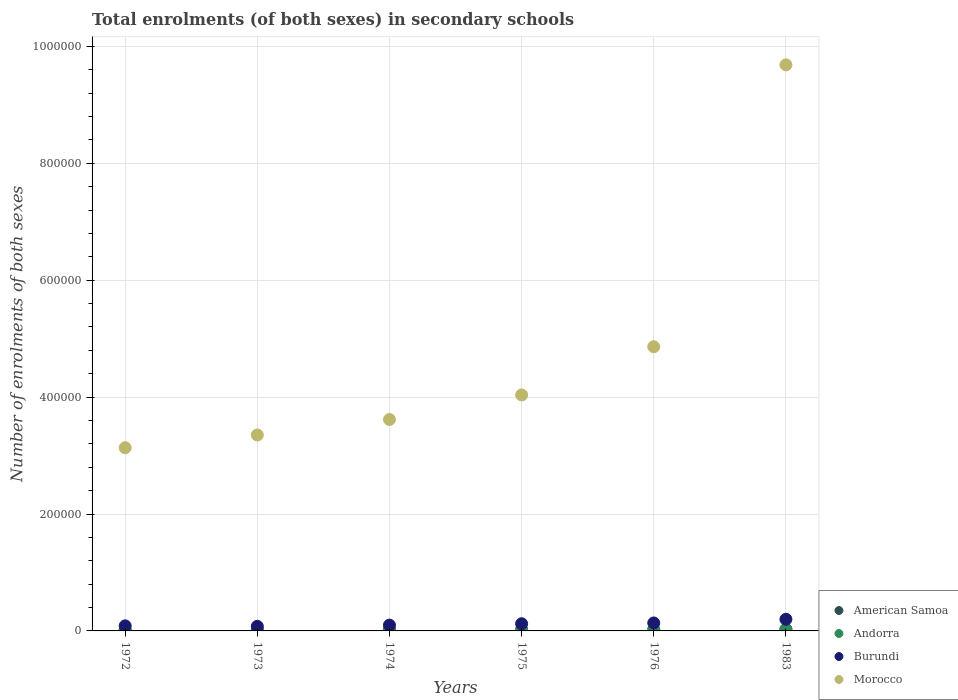How many different coloured dotlines are there?
Offer a terse response. 4. Is the number of dotlines equal to the number of legend labels?
Make the answer very short. Yes. What is the number of enrolments in secondary schools in Burundi in 1983?
Your answer should be very brief. 1.99e+04. Across all years, what is the maximum number of enrolments in secondary schools in Morocco?
Keep it short and to the point. 9.68e+05. Across all years, what is the minimum number of enrolments in secondary schools in Morocco?
Your answer should be very brief. 3.13e+05. In which year was the number of enrolments in secondary schools in American Samoa maximum?
Offer a terse response. 1983. In which year was the number of enrolments in secondary schools in Andorra minimum?
Offer a very short reply. 1973. What is the total number of enrolments in secondary schools in Burundi in the graph?
Your answer should be very brief. 7.23e+04. What is the difference between the number of enrolments in secondary schools in American Samoa in 1974 and that in 1976?
Your answer should be compact. -108. What is the difference between the number of enrolments in secondary schools in Andorra in 1975 and the number of enrolments in secondary schools in American Samoa in 1983?
Provide a succinct answer. -1660. What is the average number of enrolments in secondary schools in Burundi per year?
Ensure brevity in your answer.  1.21e+04. In the year 1976, what is the difference between the number of enrolments in secondary schools in Morocco and number of enrolments in secondary schools in Andorra?
Make the answer very short. 4.84e+05. What is the ratio of the number of enrolments in secondary schools in Andorra in 1972 to that in 1974?
Offer a terse response. 0.81. Is the number of enrolments in secondary schools in Morocco in 1972 less than that in 1973?
Provide a succinct answer. Yes. What is the difference between the highest and the second highest number of enrolments in secondary schools in Burundi?
Provide a short and direct response. 6294. What is the difference between the highest and the lowest number of enrolments in secondary schools in American Samoa?
Give a very brief answer. 694. Is the sum of the number of enrolments in secondary schools in Burundi in 1974 and 1975 greater than the maximum number of enrolments in secondary schools in Morocco across all years?
Your answer should be very brief. No. Is it the case that in every year, the sum of the number of enrolments in secondary schools in Morocco and number of enrolments in secondary schools in Andorra  is greater than the sum of number of enrolments in secondary schools in Burundi and number of enrolments in secondary schools in American Samoa?
Your response must be concise. Yes. Is it the case that in every year, the sum of the number of enrolments in secondary schools in Morocco and number of enrolments in secondary schools in American Samoa  is greater than the number of enrolments in secondary schools in Burundi?
Keep it short and to the point. Yes. How many years are there in the graph?
Provide a short and direct response. 6. Are the values on the major ticks of Y-axis written in scientific E-notation?
Your answer should be very brief. No. How many legend labels are there?
Your answer should be very brief. 4. What is the title of the graph?
Your answer should be compact. Total enrolments (of both sexes) in secondary schools. Does "Somalia" appear as one of the legend labels in the graph?
Provide a short and direct response. No. What is the label or title of the Y-axis?
Make the answer very short. Number of enrolments of both sexes. What is the Number of enrolments of both sexes of American Samoa in 1972?
Provide a succinct answer. 2305. What is the Number of enrolments of both sexes of Andorra in 1972?
Your answer should be compact. 723. What is the Number of enrolments of both sexes of Burundi in 1972?
Ensure brevity in your answer.  8678. What is the Number of enrolments of both sexes of Morocco in 1972?
Offer a very short reply. 3.13e+05. What is the Number of enrolments of both sexes in American Samoa in 1973?
Ensure brevity in your answer.  2484. What is the Number of enrolments of both sexes of Andorra in 1973?
Keep it short and to the point. 698. What is the Number of enrolments of both sexes of Burundi in 1973?
Keep it short and to the point. 7868. What is the Number of enrolments of both sexes in Morocco in 1973?
Your answer should be very brief. 3.35e+05. What is the Number of enrolments of both sexes of American Samoa in 1974?
Keep it short and to the point. 2392. What is the Number of enrolments of both sexes of Andorra in 1974?
Make the answer very short. 890. What is the Number of enrolments of both sexes of Burundi in 1974?
Make the answer very short. 9926. What is the Number of enrolments of both sexes of Morocco in 1974?
Your answer should be very brief. 3.62e+05. What is the Number of enrolments of both sexes in American Samoa in 1975?
Give a very brief answer. 2373. What is the Number of enrolments of both sexes of Andorra in 1975?
Make the answer very short. 1339. What is the Number of enrolments of both sexes in Burundi in 1975?
Provide a short and direct response. 1.23e+04. What is the Number of enrolments of both sexes in Morocco in 1975?
Offer a very short reply. 4.04e+05. What is the Number of enrolments of both sexes in American Samoa in 1976?
Your answer should be compact. 2500. What is the Number of enrolments of both sexes of Andorra in 1976?
Make the answer very short. 1753. What is the Number of enrolments of both sexes of Burundi in 1976?
Your answer should be very brief. 1.36e+04. What is the Number of enrolments of both sexes in Morocco in 1976?
Offer a terse response. 4.86e+05. What is the Number of enrolments of both sexes of American Samoa in 1983?
Keep it short and to the point. 2999. What is the Number of enrolments of both sexes in Andorra in 1983?
Provide a short and direct response. 2516. What is the Number of enrolments of both sexes of Burundi in 1983?
Offer a very short reply. 1.99e+04. What is the Number of enrolments of both sexes of Morocco in 1983?
Your answer should be very brief. 9.68e+05. Across all years, what is the maximum Number of enrolments of both sexes in American Samoa?
Your response must be concise. 2999. Across all years, what is the maximum Number of enrolments of both sexes of Andorra?
Keep it short and to the point. 2516. Across all years, what is the maximum Number of enrolments of both sexes of Burundi?
Ensure brevity in your answer.  1.99e+04. Across all years, what is the maximum Number of enrolments of both sexes of Morocco?
Ensure brevity in your answer.  9.68e+05. Across all years, what is the minimum Number of enrolments of both sexes of American Samoa?
Give a very brief answer. 2305. Across all years, what is the minimum Number of enrolments of both sexes of Andorra?
Offer a very short reply. 698. Across all years, what is the minimum Number of enrolments of both sexes of Burundi?
Give a very brief answer. 7868. Across all years, what is the minimum Number of enrolments of both sexes of Morocco?
Offer a terse response. 3.13e+05. What is the total Number of enrolments of both sexes in American Samoa in the graph?
Provide a succinct answer. 1.51e+04. What is the total Number of enrolments of both sexes in Andorra in the graph?
Your answer should be compact. 7919. What is the total Number of enrolments of both sexes of Burundi in the graph?
Offer a very short reply. 7.23e+04. What is the total Number of enrolments of both sexes of Morocco in the graph?
Keep it short and to the point. 2.87e+06. What is the difference between the Number of enrolments of both sexes of American Samoa in 1972 and that in 1973?
Give a very brief answer. -179. What is the difference between the Number of enrolments of both sexes in Andorra in 1972 and that in 1973?
Your answer should be compact. 25. What is the difference between the Number of enrolments of both sexes in Burundi in 1972 and that in 1973?
Offer a terse response. 810. What is the difference between the Number of enrolments of both sexes in Morocco in 1972 and that in 1973?
Your answer should be very brief. -2.18e+04. What is the difference between the Number of enrolments of both sexes of American Samoa in 1972 and that in 1974?
Your answer should be compact. -87. What is the difference between the Number of enrolments of both sexes of Andorra in 1972 and that in 1974?
Give a very brief answer. -167. What is the difference between the Number of enrolments of both sexes in Burundi in 1972 and that in 1974?
Your answer should be very brief. -1248. What is the difference between the Number of enrolments of both sexes in Morocco in 1972 and that in 1974?
Make the answer very short. -4.83e+04. What is the difference between the Number of enrolments of both sexes of American Samoa in 1972 and that in 1975?
Provide a short and direct response. -68. What is the difference between the Number of enrolments of both sexes of Andorra in 1972 and that in 1975?
Provide a succinct answer. -616. What is the difference between the Number of enrolments of both sexes in Burundi in 1972 and that in 1975?
Your answer should be very brief. -3619. What is the difference between the Number of enrolments of both sexes in Morocco in 1972 and that in 1975?
Offer a very short reply. -9.02e+04. What is the difference between the Number of enrolments of both sexes in American Samoa in 1972 and that in 1976?
Give a very brief answer. -195. What is the difference between the Number of enrolments of both sexes in Andorra in 1972 and that in 1976?
Your answer should be very brief. -1030. What is the difference between the Number of enrolments of both sexes in Burundi in 1972 and that in 1976?
Your response must be concise. -4945. What is the difference between the Number of enrolments of both sexes in Morocco in 1972 and that in 1976?
Your answer should be compact. -1.73e+05. What is the difference between the Number of enrolments of both sexes in American Samoa in 1972 and that in 1983?
Make the answer very short. -694. What is the difference between the Number of enrolments of both sexes of Andorra in 1972 and that in 1983?
Make the answer very short. -1793. What is the difference between the Number of enrolments of both sexes of Burundi in 1972 and that in 1983?
Ensure brevity in your answer.  -1.12e+04. What is the difference between the Number of enrolments of both sexes in Morocco in 1972 and that in 1983?
Ensure brevity in your answer.  -6.55e+05. What is the difference between the Number of enrolments of both sexes of American Samoa in 1973 and that in 1974?
Your answer should be very brief. 92. What is the difference between the Number of enrolments of both sexes of Andorra in 1973 and that in 1974?
Offer a terse response. -192. What is the difference between the Number of enrolments of both sexes in Burundi in 1973 and that in 1974?
Keep it short and to the point. -2058. What is the difference between the Number of enrolments of both sexes of Morocco in 1973 and that in 1974?
Your answer should be compact. -2.65e+04. What is the difference between the Number of enrolments of both sexes in American Samoa in 1973 and that in 1975?
Offer a terse response. 111. What is the difference between the Number of enrolments of both sexes of Andorra in 1973 and that in 1975?
Make the answer very short. -641. What is the difference between the Number of enrolments of both sexes of Burundi in 1973 and that in 1975?
Your answer should be compact. -4429. What is the difference between the Number of enrolments of both sexes in Morocco in 1973 and that in 1975?
Make the answer very short. -6.85e+04. What is the difference between the Number of enrolments of both sexes of Andorra in 1973 and that in 1976?
Keep it short and to the point. -1055. What is the difference between the Number of enrolments of both sexes of Burundi in 1973 and that in 1976?
Give a very brief answer. -5755. What is the difference between the Number of enrolments of both sexes in Morocco in 1973 and that in 1976?
Offer a terse response. -1.51e+05. What is the difference between the Number of enrolments of both sexes in American Samoa in 1973 and that in 1983?
Provide a succinct answer. -515. What is the difference between the Number of enrolments of both sexes of Andorra in 1973 and that in 1983?
Offer a very short reply. -1818. What is the difference between the Number of enrolments of both sexes in Burundi in 1973 and that in 1983?
Keep it short and to the point. -1.20e+04. What is the difference between the Number of enrolments of both sexes of Morocco in 1973 and that in 1983?
Your response must be concise. -6.33e+05. What is the difference between the Number of enrolments of both sexes in American Samoa in 1974 and that in 1975?
Offer a terse response. 19. What is the difference between the Number of enrolments of both sexes in Andorra in 1974 and that in 1975?
Offer a very short reply. -449. What is the difference between the Number of enrolments of both sexes of Burundi in 1974 and that in 1975?
Offer a terse response. -2371. What is the difference between the Number of enrolments of both sexes of Morocco in 1974 and that in 1975?
Make the answer very short. -4.19e+04. What is the difference between the Number of enrolments of both sexes in American Samoa in 1974 and that in 1976?
Ensure brevity in your answer.  -108. What is the difference between the Number of enrolments of both sexes in Andorra in 1974 and that in 1976?
Ensure brevity in your answer.  -863. What is the difference between the Number of enrolments of both sexes in Burundi in 1974 and that in 1976?
Provide a short and direct response. -3697. What is the difference between the Number of enrolments of both sexes of Morocco in 1974 and that in 1976?
Give a very brief answer. -1.24e+05. What is the difference between the Number of enrolments of both sexes in American Samoa in 1974 and that in 1983?
Your answer should be very brief. -607. What is the difference between the Number of enrolments of both sexes in Andorra in 1974 and that in 1983?
Your answer should be very brief. -1626. What is the difference between the Number of enrolments of both sexes of Burundi in 1974 and that in 1983?
Your answer should be very brief. -9991. What is the difference between the Number of enrolments of both sexes of Morocco in 1974 and that in 1983?
Make the answer very short. -6.07e+05. What is the difference between the Number of enrolments of both sexes of American Samoa in 1975 and that in 1976?
Offer a terse response. -127. What is the difference between the Number of enrolments of both sexes in Andorra in 1975 and that in 1976?
Keep it short and to the point. -414. What is the difference between the Number of enrolments of both sexes in Burundi in 1975 and that in 1976?
Offer a terse response. -1326. What is the difference between the Number of enrolments of both sexes in Morocco in 1975 and that in 1976?
Offer a terse response. -8.25e+04. What is the difference between the Number of enrolments of both sexes in American Samoa in 1975 and that in 1983?
Offer a very short reply. -626. What is the difference between the Number of enrolments of both sexes in Andorra in 1975 and that in 1983?
Your answer should be compact. -1177. What is the difference between the Number of enrolments of both sexes in Burundi in 1975 and that in 1983?
Provide a succinct answer. -7620. What is the difference between the Number of enrolments of both sexes of Morocco in 1975 and that in 1983?
Your answer should be very brief. -5.65e+05. What is the difference between the Number of enrolments of both sexes in American Samoa in 1976 and that in 1983?
Give a very brief answer. -499. What is the difference between the Number of enrolments of both sexes in Andorra in 1976 and that in 1983?
Offer a terse response. -763. What is the difference between the Number of enrolments of both sexes of Burundi in 1976 and that in 1983?
Make the answer very short. -6294. What is the difference between the Number of enrolments of both sexes of Morocco in 1976 and that in 1983?
Offer a very short reply. -4.82e+05. What is the difference between the Number of enrolments of both sexes in American Samoa in 1972 and the Number of enrolments of both sexes in Andorra in 1973?
Provide a succinct answer. 1607. What is the difference between the Number of enrolments of both sexes in American Samoa in 1972 and the Number of enrolments of both sexes in Burundi in 1973?
Provide a succinct answer. -5563. What is the difference between the Number of enrolments of both sexes in American Samoa in 1972 and the Number of enrolments of both sexes in Morocco in 1973?
Your answer should be very brief. -3.33e+05. What is the difference between the Number of enrolments of both sexes in Andorra in 1972 and the Number of enrolments of both sexes in Burundi in 1973?
Your answer should be very brief. -7145. What is the difference between the Number of enrolments of both sexes in Andorra in 1972 and the Number of enrolments of both sexes in Morocco in 1973?
Provide a succinct answer. -3.34e+05. What is the difference between the Number of enrolments of both sexes of Burundi in 1972 and the Number of enrolments of both sexes of Morocco in 1973?
Your response must be concise. -3.27e+05. What is the difference between the Number of enrolments of both sexes in American Samoa in 1972 and the Number of enrolments of both sexes in Andorra in 1974?
Your answer should be very brief. 1415. What is the difference between the Number of enrolments of both sexes of American Samoa in 1972 and the Number of enrolments of both sexes of Burundi in 1974?
Give a very brief answer. -7621. What is the difference between the Number of enrolments of both sexes in American Samoa in 1972 and the Number of enrolments of both sexes in Morocco in 1974?
Provide a short and direct response. -3.59e+05. What is the difference between the Number of enrolments of both sexes in Andorra in 1972 and the Number of enrolments of both sexes in Burundi in 1974?
Make the answer very short. -9203. What is the difference between the Number of enrolments of both sexes of Andorra in 1972 and the Number of enrolments of both sexes of Morocco in 1974?
Your response must be concise. -3.61e+05. What is the difference between the Number of enrolments of both sexes of Burundi in 1972 and the Number of enrolments of both sexes of Morocco in 1974?
Give a very brief answer. -3.53e+05. What is the difference between the Number of enrolments of both sexes in American Samoa in 1972 and the Number of enrolments of both sexes in Andorra in 1975?
Ensure brevity in your answer.  966. What is the difference between the Number of enrolments of both sexes in American Samoa in 1972 and the Number of enrolments of both sexes in Burundi in 1975?
Your answer should be very brief. -9992. What is the difference between the Number of enrolments of both sexes in American Samoa in 1972 and the Number of enrolments of both sexes in Morocco in 1975?
Your answer should be compact. -4.01e+05. What is the difference between the Number of enrolments of both sexes in Andorra in 1972 and the Number of enrolments of both sexes in Burundi in 1975?
Give a very brief answer. -1.16e+04. What is the difference between the Number of enrolments of both sexes of Andorra in 1972 and the Number of enrolments of both sexes of Morocco in 1975?
Offer a terse response. -4.03e+05. What is the difference between the Number of enrolments of both sexes in Burundi in 1972 and the Number of enrolments of both sexes in Morocco in 1975?
Give a very brief answer. -3.95e+05. What is the difference between the Number of enrolments of both sexes of American Samoa in 1972 and the Number of enrolments of both sexes of Andorra in 1976?
Provide a succinct answer. 552. What is the difference between the Number of enrolments of both sexes in American Samoa in 1972 and the Number of enrolments of both sexes in Burundi in 1976?
Offer a very short reply. -1.13e+04. What is the difference between the Number of enrolments of both sexes in American Samoa in 1972 and the Number of enrolments of both sexes in Morocco in 1976?
Offer a very short reply. -4.84e+05. What is the difference between the Number of enrolments of both sexes in Andorra in 1972 and the Number of enrolments of both sexes in Burundi in 1976?
Offer a terse response. -1.29e+04. What is the difference between the Number of enrolments of both sexes of Andorra in 1972 and the Number of enrolments of both sexes of Morocco in 1976?
Offer a terse response. -4.85e+05. What is the difference between the Number of enrolments of both sexes in Burundi in 1972 and the Number of enrolments of both sexes in Morocco in 1976?
Keep it short and to the point. -4.77e+05. What is the difference between the Number of enrolments of both sexes in American Samoa in 1972 and the Number of enrolments of both sexes in Andorra in 1983?
Your answer should be very brief. -211. What is the difference between the Number of enrolments of both sexes in American Samoa in 1972 and the Number of enrolments of both sexes in Burundi in 1983?
Provide a succinct answer. -1.76e+04. What is the difference between the Number of enrolments of both sexes of American Samoa in 1972 and the Number of enrolments of both sexes of Morocco in 1983?
Your answer should be very brief. -9.66e+05. What is the difference between the Number of enrolments of both sexes in Andorra in 1972 and the Number of enrolments of both sexes in Burundi in 1983?
Make the answer very short. -1.92e+04. What is the difference between the Number of enrolments of both sexes of Andorra in 1972 and the Number of enrolments of both sexes of Morocco in 1983?
Your response must be concise. -9.68e+05. What is the difference between the Number of enrolments of both sexes in Burundi in 1972 and the Number of enrolments of both sexes in Morocco in 1983?
Offer a very short reply. -9.60e+05. What is the difference between the Number of enrolments of both sexes of American Samoa in 1973 and the Number of enrolments of both sexes of Andorra in 1974?
Keep it short and to the point. 1594. What is the difference between the Number of enrolments of both sexes in American Samoa in 1973 and the Number of enrolments of both sexes in Burundi in 1974?
Make the answer very short. -7442. What is the difference between the Number of enrolments of both sexes of American Samoa in 1973 and the Number of enrolments of both sexes of Morocco in 1974?
Ensure brevity in your answer.  -3.59e+05. What is the difference between the Number of enrolments of both sexes in Andorra in 1973 and the Number of enrolments of both sexes in Burundi in 1974?
Make the answer very short. -9228. What is the difference between the Number of enrolments of both sexes in Andorra in 1973 and the Number of enrolments of both sexes in Morocco in 1974?
Provide a short and direct response. -3.61e+05. What is the difference between the Number of enrolments of both sexes in Burundi in 1973 and the Number of enrolments of both sexes in Morocco in 1974?
Ensure brevity in your answer.  -3.54e+05. What is the difference between the Number of enrolments of both sexes of American Samoa in 1973 and the Number of enrolments of both sexes of Andorra in 1975?
Make the answer very short. 1145. What is the difference between the Number of enrolments of both sexes of American Samoa in 1973 and the Number of enrolments of both sexes of Burundi in 1975?
Provide a succinct answer. -9813. What is the difference between the Number of enrolments of both sexes of American Samoa in 1973 and the Number of enrolments of both sexes of Morocco in 1975?
Give a very brief answer. -4.01e+05. What is the difference between the Number of enrolments of both sexes of Andorra in 1973 and the Number of enrolments of both sexes of Burundi in 1975?
Provide a short and direct response. -1.16e+04. What is the difference between the Number of enrolments of both sexes in Andorra in 1973 and the Number of enrolments of both sexes in Morocco in 1975?
Offer a terse response. -4.03e+05. What is the difference between the Number of enrolments of both sexes of Burundi in 1973 and the Number of enrolments of both sexes of Morocco in 1975?
Your answer should be very brief. -3.96e+05. What is the difference between the Number of enrolments of both sexes in American Samoa in 1973 and the Number of enrolments of both sexes in Andorra in 1976?
Provide a succinct answer. 731. What is the difference between the Number of enrolments of both sexes in American Samoa in 1973 and the Number of enrolments of both sexes in Burundi in 1976?
Your answer should be compact. -1.11e+04. What is the difference between the Number of enrolments of both sexes in American Samoa in 1973 and the Number of enrolments of both sexes in Morocco in 1976?
Offer a very short reply. -4.84e+05. What is the difference between the Number of enrolments of both sexes in Andorra in 1973 and the Number of enrolments of both sexes in Burundi in 1976?
Provide a short and direct response. -1.29e+04. What is the difference between the Number of enrolments of both sexes of Andorra in 1973 and the Number of enrolments of both sexes of Morocco in 1976?
Provide a succinct answer. -4.85e+05. What is the difference between the Number of enrolments of both sexes in Burundi in 1973 and the Number of enrolments of both sexes in Morocco in 1976?
Give a very brief answer. -4.78e+05. What is the difference between the Number of enrolments of both sexes in American Samoa in 1973 and the Number of enrolments of both sexes in Andorra in 1983?
Provide a succinct answer. -32. What is the difference between the Number of enrolments of both sexes of American Samoa in 1973 and the Number of enrolments of both sexes of Burundi in 1983?
Provide a short and direct response. -1.74e+04. What is the difference between the Number of enrolments of both sexes of American Samoa in 1973 and the Number of enrolments of both sexes of Morocco in 1983?
Your answer should be very brief. -9.66e+05. What is the difference between the Number of enrolments of both sexes in Andorra in 1973 and the Number of enrolments of both sexes in Burundi in 1983?
Offer a terse response. -1.92e+04. What is the difference between the Number of enrolments of both sexes in Andorra in 1973 and the Number of enrolments of both sexes in Morocco in 1983?
Provide a short and direct response. -9.68e+05. What is the difference between the Number of enrolments of both sexes of Burundi in 1973 and the Number of enrolments of both sexes of Morocco in 1983?
Your answer should be compact. -9.60e+05. What is the difference between the Number of enrolments of both sexes in American Samoa in 1974 and the Number of enrolments of both sexes in Andorra in 1975?
Provide a succinct answer. 1053. What is the difference between the Number of enrolments of both sexes in American Samoa in 1974 and the Number of enrolments of both sexes in Burundi in 1975?
Make the answer very short. -9905. What is the difference between the Number of enrolments of both sexes of American Samoa in 1974 and the Number of enrolments of both sexes of Morocco in 1975?
Give a very brief answer. -4.01e+05. What is the difference between the Number of enrolments of both sexes of Andorra in 1974 and the Number of enrolments of both sexes of Burundi in 1975?
Provide a succinct answer. -1.14e+04. What is the difference between the Number of enrolments of both sexes of Andorra in 1974 and the Number of enrolments of both sexes of Morocco in 1975?
Keep it short and to the point. -4.03e+05. What is the difference between the Number of enrolments of both sexes of Burundi in 1974 and the Number of enrolments of both sexes of Morocco in 1975?
Your answer should be compact. -3.94e+05. What is the difference between the Number of enrolments of both sexes in American Samoa in 1974 and the Number of enrolments of both sexes in Andorra in 1976?
Offer a terse response. 639. What is the difference between the Number of enrolments of both sexes in American Samoa in 1974 and the Number of enrolments of both sexes in Burundi in 1976?
Ensure brevity in your answer.  -1.12e+04. What is the difference between the Number of enrolments of both sexes of American Samoa in 1974 and the Number of enrolments of both sexes of Morocco in 1976?
Give a very brief answer. -4.84e+05. What is the difference between the Number of enrolments of both sexes in Andorra in 1974 and the Number of enrolments of both sexes in Burundi in 1976?
Your response must be concise. -1.27e+04. What is the difference between the Number of enrolments of both sexes of Andorra in 1974 and the Number of enrolments of both sexes of Morocco in 1976?
Ensure brevity in your answer.  -4.85e+05. What is the difference between the Number of enrolments of both sexes of Burundi in 1974 and the Number of enrolments of both sexes of Morocco in 1976?
Provide a short and direct response. -4.76e+05. What is the difference between the Number of enrolments of both sexes of American Samoa in 1974 and the Number of enrolments of both sexes of Andorra in 1983?
Ensure brevity in your answer.  -124. What is the difference between the Number of enrolments of both sexes of American Samoa in 1974 and the Number of enrolments of both sexes of Burundi in 1983?
Ensure brevity in your answer.  -1.75e+04. What is the difference between the Number of enrolments of both sexes of American Samoa in 1974 and the Number of enrolments of both sexes of Morocco in 1983?
Offer a very short reply. -9.66e+05. What is the difference between the Number of enrolments of both sexes of Andorra in 1974 and the Number of enrolments of both sexes of Burundi in 1983?
Make the answer very short. -1.90e+04. What is the difference between the Number of enrolments of both sexes in Andorra in 1974 and the Number of enrolments of both sexes in Morocco in 1983?
Your response must be concise. -9.67e+05. What is the difference between the Number of enrolments of both sexes in Burundi in 1974 and the Number of enrolments of both sexes in Morocco in 1983?
Your answer should be very brief. -9.58e+05. What is the difference between the Number of enrolments of both sexes of American Samoa in 1975 and the Number of enrolments of both sexes of Andorra in 1976?
Offer a terse response. 620. What is the difference between the Number of enrolments of both sexes of American Samoa in 1975 and the Number of enrolments of both sexes of Burundi in 1976?
Provide a short and direct response. -1.12e+04. What is the difference between the Number of enrolments of both sexes in American Samoa in 1975 and the Number of enrolments of both sexes in Morocco in 1976?
Offer a very short reply. -4.84e+05. What is the difference between the Number of enrolments of both sexes in Andorra in 1975 and the Number of enrolments of both sexes in Burundi in 1976?
Provide a short and direct response. -1.23e+04. What is the difference between the Number of enrolments of both sexes of Andorra in 1975 and the Number of enrolments of both sexes of Morocco in 1976?
Offer a very short reply. -4.85e+05. What is the difference between the Number of enrolments of both sexes in Burundi in 1975 and the Number of enrolments of both sexes in Morocco in 1976?
Provide a short and direct response. -4.74e+05. What is the difference between the Number of enrolments of both sexes in American Samoa in 1975 and the Number of enrolments of both sexes in Andorra in 1983?
Your response must be concise. -143. What is the difference between the Number of enrolments of both sexes of American Samoa in 1975 and the Number of enrolments of both sexes of Burundi in 1983?
Offer a very short reply. -1.75e+04. What is the difference between the Number of enrolments of both sexes in American Samoa in 1975 and the Number of enrolments of both sexes in Morocco in 1983?
Provide a short and direct response. -9.66e+05. What is the difference between the Number of enrolments of both sexes of Andorra in 1975 and the Number of enrolments of both sexes of Burundi in 1983?
Provide a short and direct response. -1.86e+04. What is the difference between the Number of enrolments of both sexes of Andorra in 1975 and the Number of enrolments of both sexes of Morocco in 1983?
Keep it short and to the point. -9.67e+05. What is the difference between the Number of enrolments of both sexes in Burundi in 1975 and the Number of enrolments of both sexes in Morocco in 1983?
Provide a short and direct response. -9.56e+05. What is the difference between the Number of enrolments of both sexes of American Samoa in 1976 and the Number of enrolments of both sexes of Andorra in 1983?
Your answer should be compact. -16. What is the difference between the Number of enrolments of both sexes of American Samoa in 1976 and the Number of enrolments of both sexes of Burundi in 1983?
Offer a very short reply. -1.74e+04. What is the difference between the Number of enrolments of both sexes of American Samoa in 1976 and the Number of enrolments of both sexes of Morocco in 1983?
Make the answer very short. -9.66e+05. What is the difference between the Number of enrolments of both sexes of Andorra in 1976 and the Number of enrolments of both sexes of Burundi in 1983?
Your answer should be very brief. -1.82e+04. What is the difference between the Number of enrolments of both sexes in Andorra in 1976 and the Number of enrolments of both sexes in Morocco in 1983?
Offer a very short reply. -9.67e+05. What is the difference between the Number of enrolments of both sexes of Burundi in 1976 and the Number of enrolments of both sexes of Morocco in 1983?
Keep it short and to the point. -9.55e+05. What is the average Number of enrolments of both sexes of American Samoa per year?
Your answer should be compact. 2508.83. What is the average Number of enrolments of both sexes of Andorra per year?
Your response must be concise. 1319.83. What is the average Number of enrolments of both sexes of Burundi per year?
Provide a short and direct response. 1.21e+04. What is the average Number of enrolments of both sexes of Morocco per year?
Offer a terse response. 4.78e+05. In the year 1972, what is the difference between the Number of enrolments of both sexes in American Samoa and Number of enrolments of both sexes in Andorra?
Your answer should be compact. 1582. In the year 1972, what is the difference between the Number of enrolments of both sexes of American Samoa and Number of enrolments of both sexes of Burundi?
Provide a short and direct response. -6373. In the year 1972, what is the difference between the Number of enrolments of both sexes in American Samoa and Number of enrolments of both sexes in Morocco?
Keep it short and to the point. -3.11e+05. In the year 1972, what is the difference between the Number of enrolments of both sexes in Andorra and Number of enrolments of both sexes in Burundi?
Ensure brevity in your answer.  -7955. In the year 1972, what is the difference between the Number of enrolments of both sexes in Andorra and Number of enrolments of both sexes in Morocco?
Make the answer very short. -3.13e+05. In the year 1972, what is the difference between the Number of enrolments of both sexes in Burundi and Number of enrolments of both sexes in Morocco?
Offer a very short reply. -3.05e+05. In the year 1973, what is the difference between the Number of enrolments of both sexes of American Samoa and Number of enrolments of both sexes of Andorra?
Offer a very short reply. 1786. In the year 1973, what is the difference between the Number of enrolments of both sexes in American Samoa and Number of enrolments of both sexes in Burundi?
Ensure brevity in your answer.  -5384. In the year 1973, what is the difference between the Number of enrolments of both sexes of American Samoa and Number of enrolments of both sexes of Morocco?
Make the answer very short. -3.33e+05. In the year 1973, what is the difference between the Number of enrolments of both sexes in Andorra and Number of enrolments of both sexes in Burundi?
Ensure brevity in your answer.  -7170. In the year 1973, what is the difference between the Number of enrolments of both sexes of Andorra and Number of enrolments of both sexes of Morocco?
Make the answer very short. -3.34e+05. In the year 1973, what is the difference between the Number of enrolments of both sexes of Burundi and Number of enrolments of both sexes of Morocco?
Your answer should be compact. -3.27e+05. In the year 1974, what is the difference between the Number of enrolments of both sexes of American Samoa and Number of enrolments of both sexes of Andorra?
Provide a succinct answer. 1502. In the year 1974, what is the difference between the Number of enrolments of both sexes in American Samoa and Number of enrolments of both sexes in Burundi?
Keep it short and to the point. -7534. In the year 1974, what is the difference between the Number of enrolments of both sexes in American Samoa and Number of enrolments of both sexes in Morocco?
Provide a short and direct response. -3.59e+05. In the year 1974, what is the difference between the Number of enrolments of both sexes of Andorra and Number of enrolments of both sexes of Burundi?
Your answer should be compact. -9036. In the year 1974, what is the difference between the Number of enrolments of both sexes in Andorra and Number of enrolments of both sexes in Morocco?
Make the answer very short. -3.61e+05. In the year 1974, what is the difference between the Number of enrolments of both sexes in Burundi and Number of enrolments of both sexes in Morocco?
Offer a very short reply. -3.52e+05. In the year 1975, what is the difference between the Number of enrolments of both sexes in American Samoa and Number of enrolments of both sexes in Andorra?
Provide a short and direct response. 1034. In the year 1975, what is the difference between the Number of enrolments of both sexes of American Samoa and Number of enrolments of both sexes of Burundi?
Make the answer very short. -9924. In the year 1975, what is the difference between the Number of enrolments of both sexes in American Samoa and Number of enrolments of both sexes in Morocco?
Offer a terse response. -4.01e+05. In the year 1975, what is the difference between the Number of enrolments of both sexes of Andorra and Number of enrolments of both sexes of Burundi?
Your response must be concise. -1.10e+04. In the year 1975, what is the difference between the Number of enrolments of both sexes of Andorra and Number of enrolments of both sexes of Morocco?
Offer a very short reply. -4.02e+05. In the year 1975, what is the difference between the Number of enrolments of both sexes in Burundi and Number of enrolments of both sexes in Morocco?
Make the answer very short. -3.91e+05. In the year 1976, what is the difference between the Number of enrolments of both sexes in American Samoa and Number of enrolments of both sexes in Andorra?
Offer a terse response. 747. In the year 1976, what is the difference between the Number of enrolments of both sexes in American Samoa and Number of enrolments of both sexes in Burundi?
Give a very brief answer. -1.11e+04. In the year 1976, what is the difference between the Number of enrolments of both sexes of American Samoa and Number of enrolments of both sexes of Morocco?
Offer a terse response. -4.84e+05. In the year 1976, what is the difference between the Number of enrolments of both sexes in Andorra and Number of enrolments of both sexes in Burundi?
Keep it short and to the point. -1.19e+04. In the year 1976, what is the difference between the Number of enrolments of both sexes of Andorra and Number of enrolments of both sexes of Morocco?
Give a very brief answer. -4.84e+05. In the year 1976, what is the difference between the Number of enrolments of both sexes in Burundi and Number of enrolments of both sexes in Morocco?
Provide a short and direct response. -4.73e+05. In the year 1983, what is the difference between the Number of enrolments of both sexes of American Samoa and Number of enrolments of both sexes of Andorra?
Provide a short and direct response. 483. In the year 1983, what is the difference between the Number of enrolments of both sexes in American Samoa and Number of enrolments of both sexes in Burundi?
Give a very brief answer. -1.69e+04. In the year 1983, what is the difference between the Number of enrolments of both sexes of American Samoa and Number of enrolments of both sexes of Morocco?
Offer a very short reply. -9.65e+05. In the year 1983, what is the difference between the Number of enrolments of both sexes of Andorra and Number of enrolments of both sexes of Burundi?
Ensure brevity in your answer.  -1.74e+04. In the year 1983, what is the difference between the Number of enrolments of both sexes of Andorra and Number of enrolments of both sexes of Morocco?
Ensure brevity in your answer.  -9.66e+05. In the year 1983, what is the difference between the Number of enrolments of both sexes in Burundi and Number of enrolments of both sexes in Morocco?
Make the answer very short. -9.48e+05. What is the ratio of the Number of enrolments of both sexes of American Samoa in 1972 to that in 1973?
Offer a terse response. 0.93. What is the ratio of the Number of enrolments of both sexes of Andorra in 1972 to that in 1973?
Provide a short and direct response. 1.04. What is the ratio of the Number of enrolments of both sexes of Burundi in 1972 to that in 1973?
Your response must be concise. 1.1. What is the ratio of the Number of enrolments of both sexes of Morocco in 1972 to that in 1973?
Provide a short and direct response. 0.94. What is the ratio of the Number of enrolments of both sexes of American Samoa in 1972 to that in 1974?
Your response must be concise. 0.96. What is the ratio of the Number of enrolments of both sexes of Andorra in 1972 to that in 1974?
Offer a terse response. 0.81. What is the ratio of the Number of enrolments of both sexes in Burundi in 1972 to that in 1974?
Keep it short and to the point. 0.87. What is the ratio of the Number of enrolments of both sexes of Morocco in 1972 to that in 1974?
Give a very brief answer. 0.87. What is the ratio of the Number of enrolments of both sexes of American Samoa in 1972 to that in 1975?
Your answer should be very brief. 0.97. What is the ratio of the Number of enrolments of both sexes of Andorra in 1972 to that in 1975?
Your answer should be very brief. 0.54. What is the ratio of the Number of enrolments of both sexes in Burundi in 1972 to that in 1975?
Give a very brief answer. 0.71. What is the ratio of the Number of enrolments of both sexes in Morocco in 1972 to that in 1975?
Offer a terse response. 0.78. What is the ratio of the Number of enrolments of both sexes of American Samoa in 1972 to that in 1976?
Offer a terse response. 0.92. What is the ratio of the Number of enrolments of both sexes of Andorra in 1972 to that in 1976?
Your answer should be compact. 0.41. What is the ratio of the Number of enrolments of both sexes in Burundi in 1972 to that in 1976?
Your answer should be compact. 0.64. What is the ratio of the Number of enrolments of both sexes of Morocco in 1972 to that in 1976?
Offer a very short reply. 0.64. What is the ratio of the Number of enrolments of both sexes of American Samoa in 1972 to that in 1983?
Your answer should be compact. 0.77. What is the ratio of the Number of enrolments of both sexes of Andorra in 1972 to that in 1983?
Keep it short and to the point. 0.29. What is the ratio of the Number of enrolments of both sexes in Burundi in 1972 to that in 1983?
Your answer should be very brief. 0.44. What is the ratio of the Number of enrolments of both sexes in Morocco in 1972 to that in 1983?
Make the answer very short. 0.32. What is the ratio of the Number of enrolments of both sexes of Andorra in 1973 to that in 1974?
Provide a succinct answer. 0.78. What is the ratio of the Number of enrolments of both sexes of Burundi in 1973 to that in 1974?
Your answer should be very brief. 0.79. What is the ratio of the Number of enrolments of both sexes in Morocco in 1973 to that in 1974?
Your response must be concise. 0.93. What is the ratio of the Number of enrolments of both sexes of American Samoa in 1973 to that in 1975?
Keep it short and to the point. 1.05. What is the ratio of the Number of enrolments of both sexes of Andorra in 1973 to that in 1975?
Make the answer very short. 0.52. What is the ratio of the Number of enrolments of both sexes of Burundi in 1973 to that in 1975?
Your response must be concise. 0.64. What is the ratio of the Number of enrolments of both sexes of Morocco in 1973 to that in 1975?
Your answer should be very brief. 0.83. What is the ratio of the Number of enrolments of both sexes in American Samoa in 1973 to that in 1976?
Ensure brevity in your answer.  0.99. What is the ratio of the Number of enrolments of both sexes of Andorra in 1973 to that in 1976?
Offer a terse response. 0.4. What is the ratio of the Number of enrolments of both sexes of Burundi in 1973 to that in 1976?
Ensure brevity in your answer.  0.58. What is the ratio of the Number of enrolments of both sexes in Morocco in 1973 to that in 1976?
Give a very brief answer. 0.69. What is the ratio of the Number of enrolments of both sexes in American Samoa in 1973 to that in 1983?
Your response must be concise. 0.83. What is the ratio of the Number of enrolments of both sexes of Andorra in 1973 to that in 1983?
Offer a terse response. 0.28. What is the ratio of the Number of enrolments of both sexes in Burundi in 1973 to that in 1983?
Your response must be concise. 0.4. What is the ratio of the Number of enrolments of both sexes of Morocco in 1973 to that in 1983?
Keep it short and to the point. 0.35. What is the ratio of the Number of enrolments of both sexes in Andorra in 1974 to that in 1975?
Your response must be concise. 0.66. What is the ratio of the Number of enrolments of both sexes of Burundi in 1974 to that in 1975?
Provide a short and direct response. 0.81. What is the ratio of the Number of enrolments of both sexes in Morocco in 1974 to that in 1975?
Ensure brevity in your answer.  0.9. What is the ratio of the Number of enrolments of both sexes in American Samoa in 1974 to that in 1976?
Make the answer very short. 0.96. What is the ratio of the Number of enrolments of both sexes of Andorra in 1974 to that in 1976?
Your answer should be very brief. 0.51. What is the ratio of the Number of enrolments of both sexes in Burundi in 1974 to that in 1976?
Provide a succinct answer. 0.73. What is the ratio of the Number of enrolments of both sexes in Morocco in 1974 to that in 1976?
Your response must be concise. 0.74. What is the ratio of the Number of enrolments of both sexes of American Samoa in 1974 to that in 1983?
Your answer should be compact. 0.8. What is the ratio of the Number of enrolments of both sexes in Andorra in 1974 to that in 1983?
Make the answer very short. 0.35. What is the ratio of the Number of enrolments of both sexes in Burundi in 1974 to that in 1983?
Offer a very short reply. 0.5. What is the ratio of the Number of enrolments of both sexes of Morocco in 1974 to that in 1983?
Offer a very short reply. 0.37. What is the ratio of the Number of enrolments of both sexes of American Samoa in 1975 to that in 1976?
Make the answer very short. 0.95. What is the ratio of the Number of enrolments of both sexes of Andorra in 1975 to that in 1976?
Keep it short and to the point. 0.76. What is the ratio of the Number of enrolments of both sexes of Burundi in 1975 to that in 1976?
Your answer should be compact. 0.9. What is the ratio of the Number of enrolments of both sexes of Morocco in 1975 to that in 1976?
Keep it short and to the point. 0.83. What is the ratio of the Number of enrolments of both sexes of American Samoa in 1975 to that in 1983?
Your answer should be compact. 0.79. What is the ratio of the Number of enrolments of both sexes in Andorra in 1975 to that in 1983?
Give a very brief answer. 0.53. What is the ratio of the Number of enrolments of both sexes in Burundi in 1975 to that in 1983?
Make the answer very short. 0.62. What is the ratio of the Number of enrolments of both sexes of Morocco in 1975 to that in 1983?
Your answer should be very brief. 0.42. What is the ratio of the Number of enrolments of both sexes in American Samoa in 1976 to that in 1983?
Make the answer very short. 0.83. What is the ratio of the Number of enrolments of both sexes of Andorra in 1976 to that in 1983?
Keep it short and to the point. 0.7. What is the ratio of the Number of enrolments of both sexes of Burundi in 1976 to that in 1983?
Keep it short and to the point. 0.68. What is the ratio of the Number of enrolments of both sexes of Morocco in 1976 to that in 1983?
Make the answer very short. 0.5. What is the difference between the highest and the second highest Number of enrolments of both sexes of American Samoa?
Keep it short and to the point. 499. What is the difference between the highest and the second highest Number of enrolments of both sexes in Andorra?
Make the answer very short. 763. What is the difference between the highest and the second highest Number of enrolments of both sexes of Burundi?
Offer a very short reply. 6294. What is the difference between the highest and the second highest Number of enrolments of both sexes in Morocco?
Your response must be concise. 4.82e+05. What is the difference between the highest and the lowest Number of enrolments of both sexes in American Samoa?
Provide a short and direct response. 694. What is the difference between the highest and the lowest Number of enrolments of both sexes of Andorra?
Provide a succinct answer. 1818. What is the difference between the highest and the lowest Number of enrolments of both sexes of Burundi?
Your answer should be very brief. 1.20e+04. What is the difference between the highest and the lowest Number of enrolments of both sexes of Morocco?
Provide a succinct answer. 6.55e+05. 